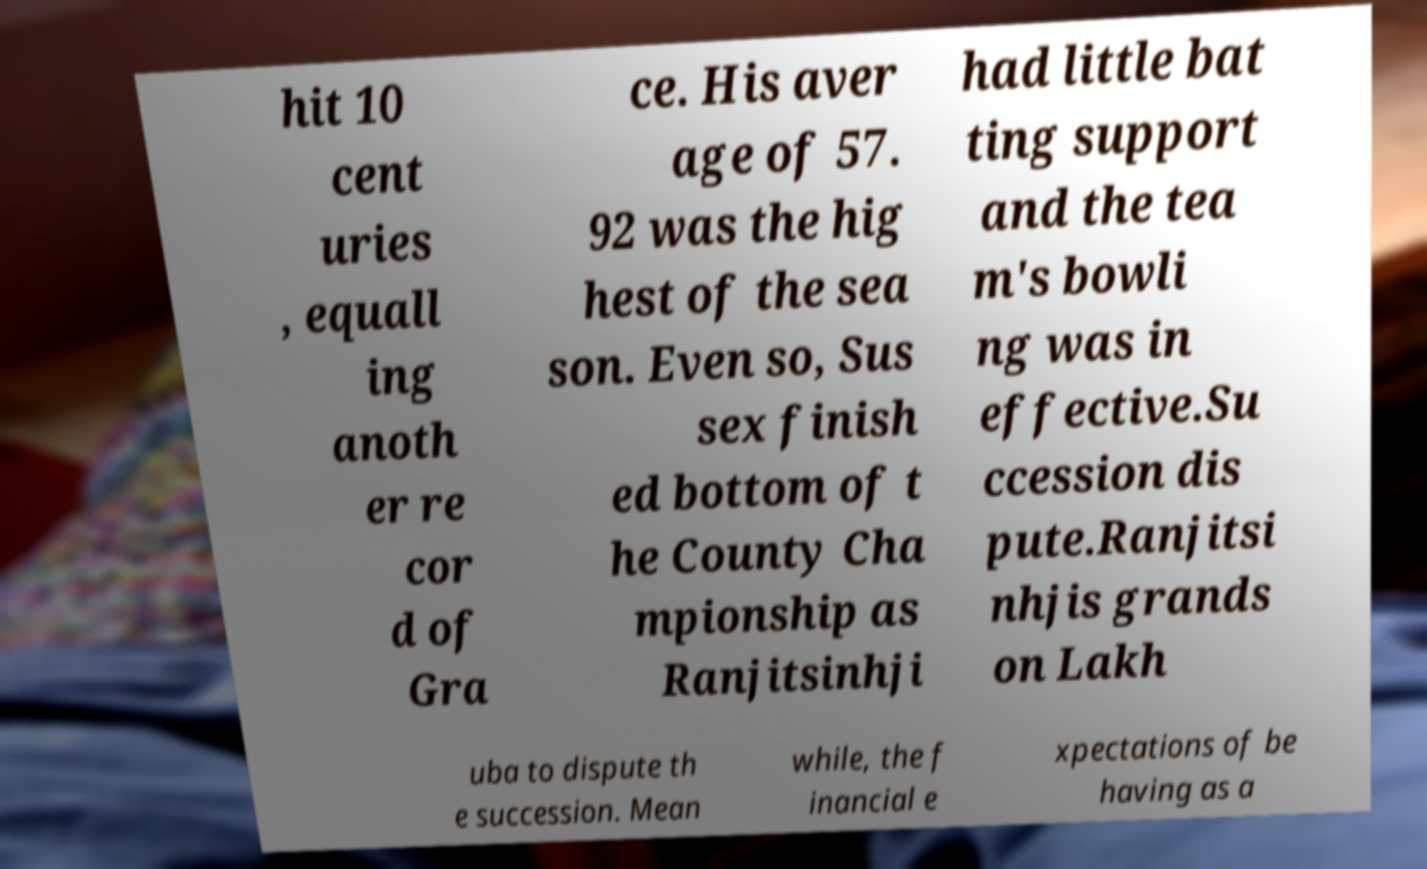Please identify and transcribe the text found in this image. hit 10 cent uries , equall ing anoth er re cor d of Gra ce. His aver age of 57. 92 was the hig hest of the sea son. Even so, Sus sex finish ed bottom of t he County Cha mpionship as Ranjitsinhji had little bat ting support and the tea m's bowli ng was in effective.Su ccession dis pute.Ranjitsi nhjis grands on Lakh uba to dispute th e succession. Mean while, the f inancial e xpectations of be having as a 